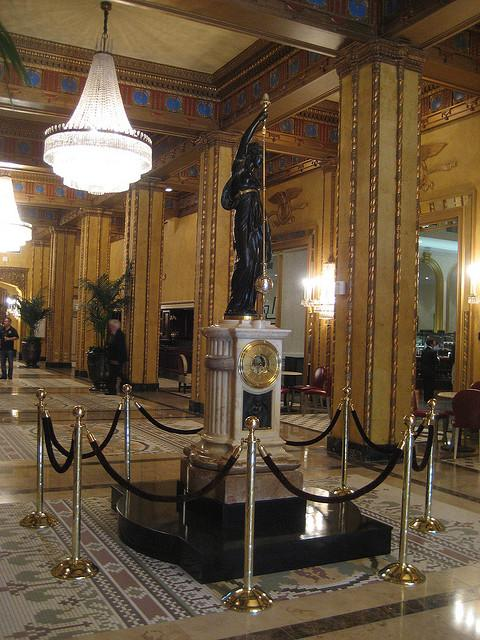Why is there a rope around this statue? Please explain your reasoning. prevent damage. The rope is used to keep people at a safe distance from the statue so they don't accidentally damage it. 